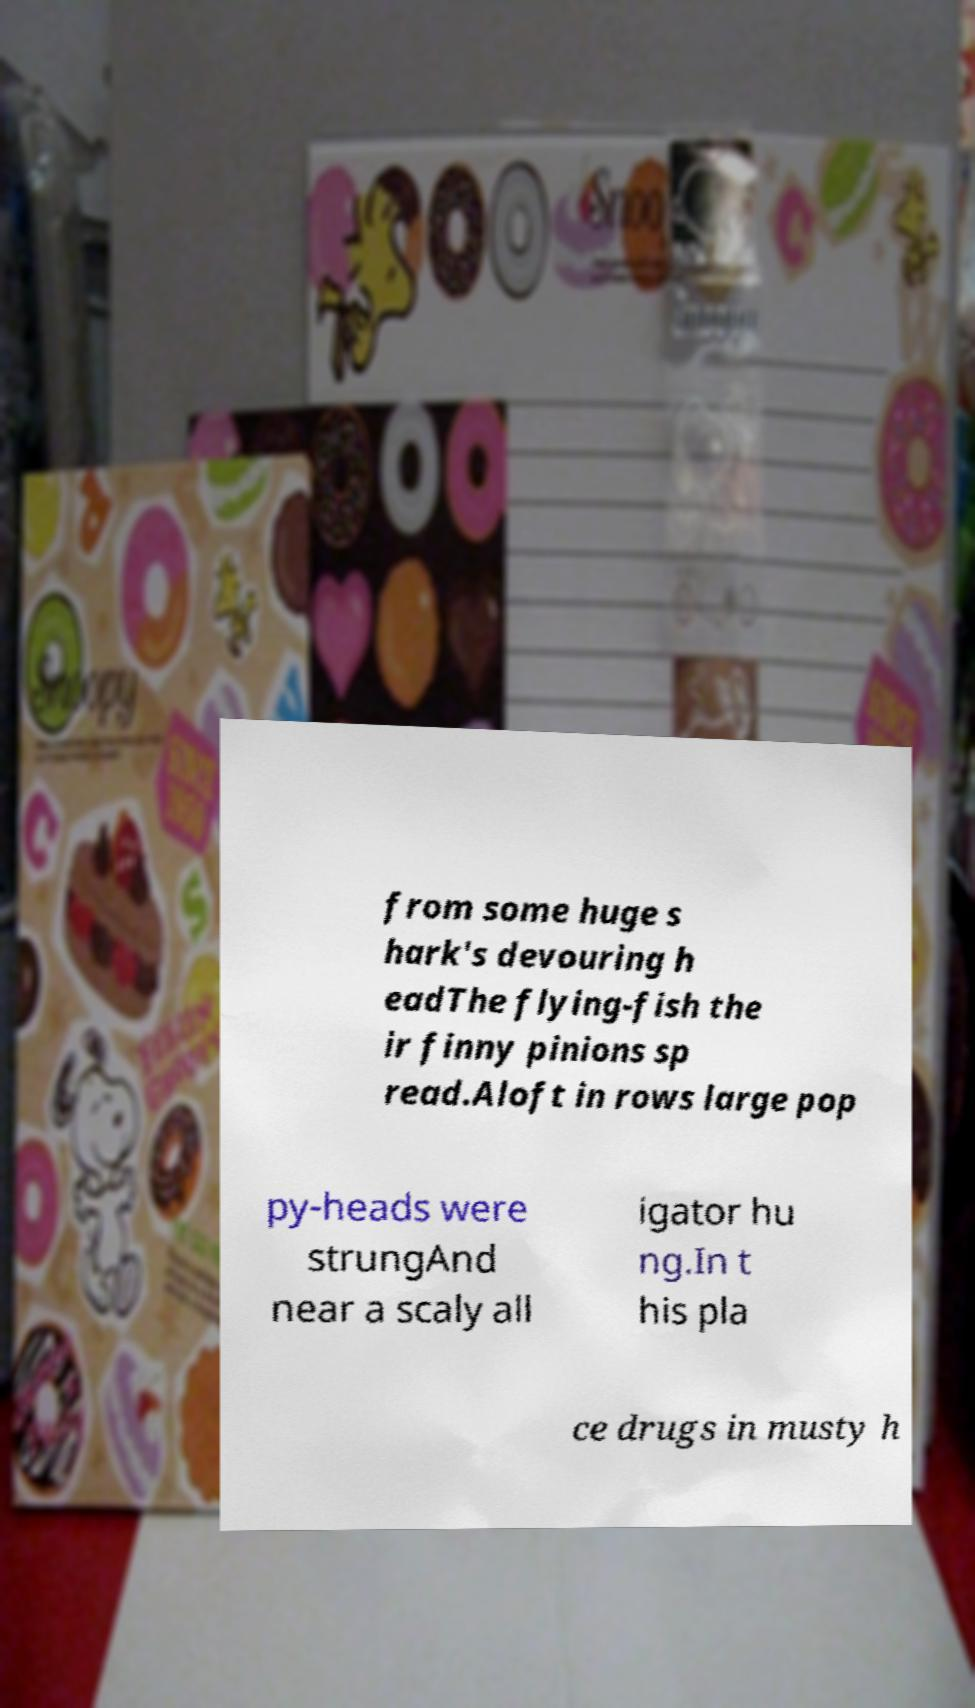Please identify and transcribe the text found in this image. from some huge s hark's devouring h eadThe flying-fish the ir finny pinions sp read.Aloft in rows large pop py-heads were strungAnd near a scaly all igator hu ng.In t his pla ce drugs in musty h 